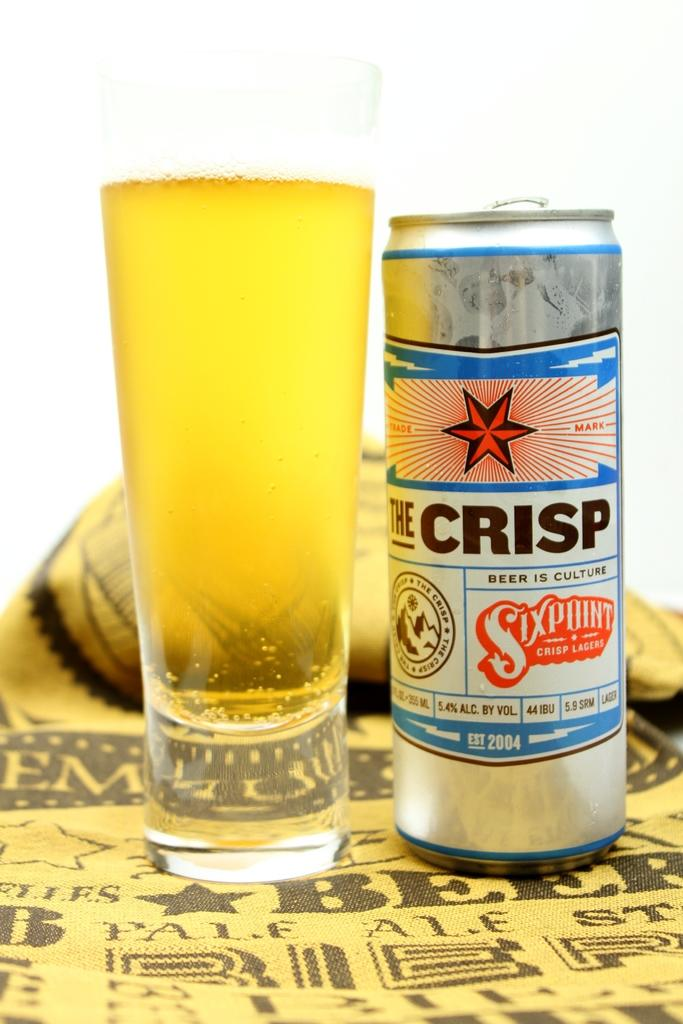<image>
Render a clear and concise summary of the photo. A full glass and a can of The Crisp beer. 